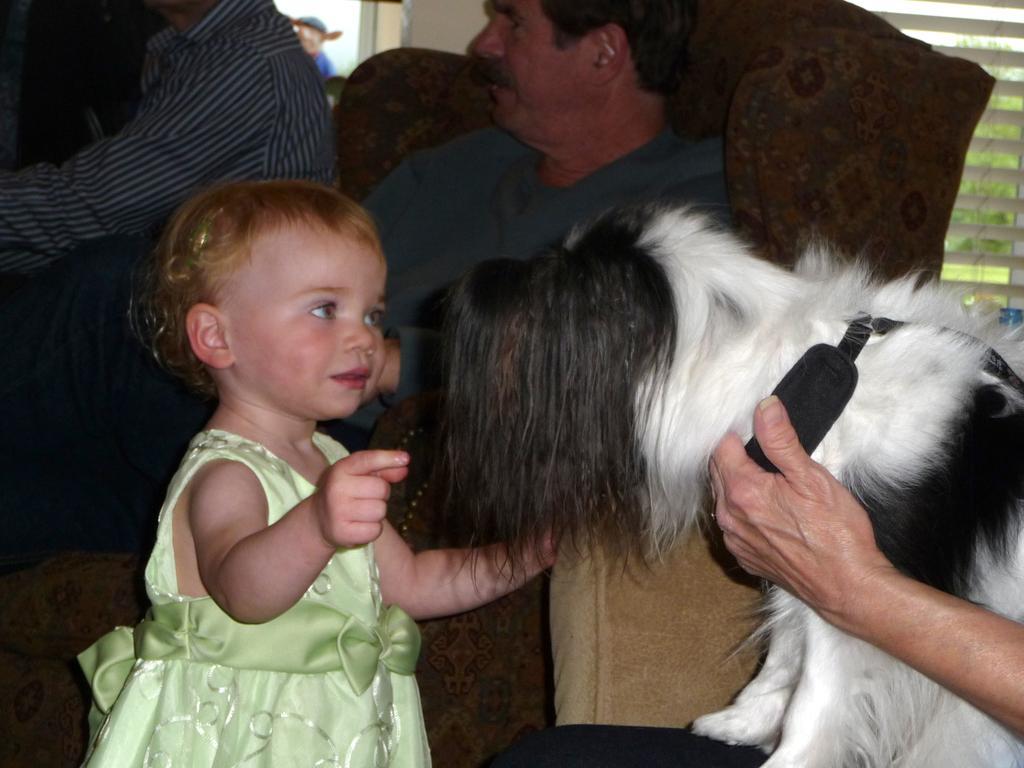Can you describe this image briefly? There is a baby girl who is looking to touch this dog which is on the lap of a man. In the background there is a man sitting on a sofa. 